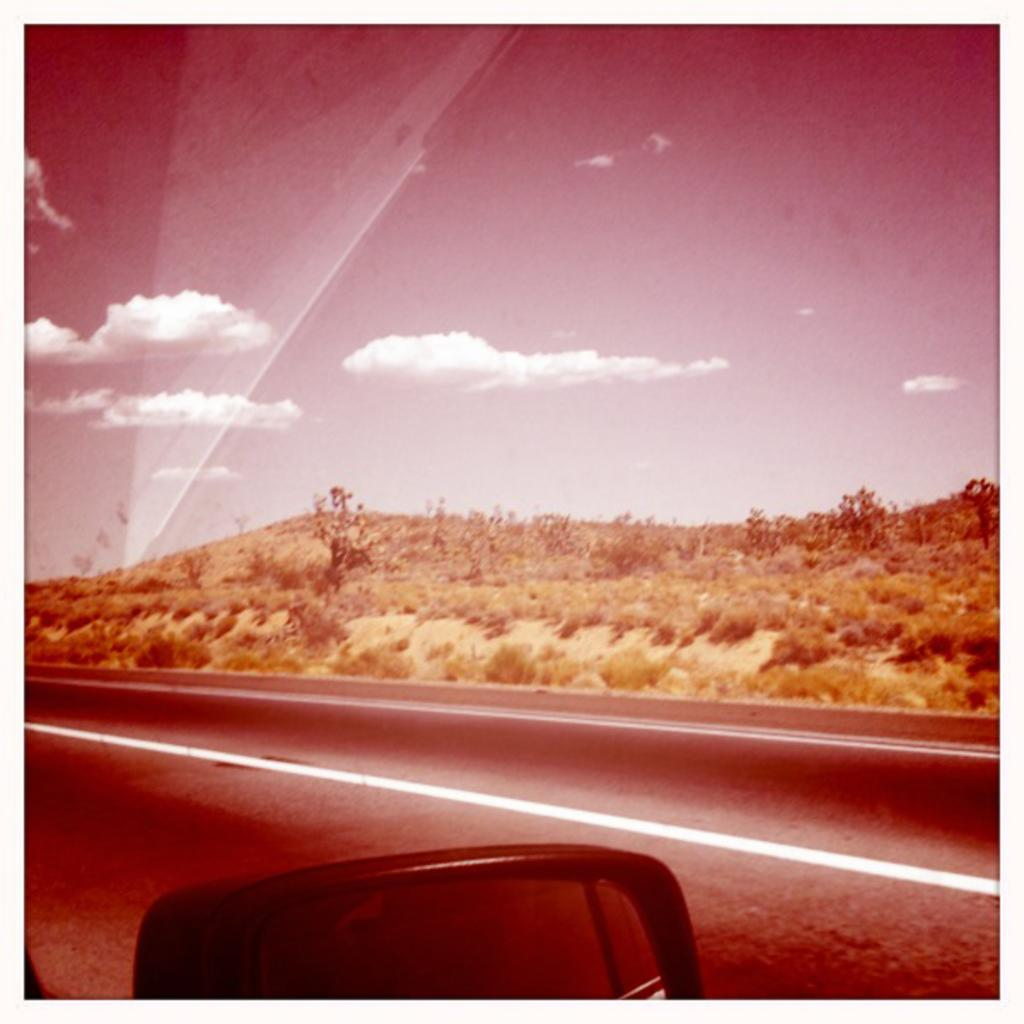What type of vegetation can be seen in the image? There are trees in the image. What is the color of the trees? The trees are green in color. What else is visible in the image besides the trees? The sky is visible in the image. What is the color of the sky? The sky is white in color. Can you identify any man-made objects in the image? Yes, there is a vehicle mirror in the image. Where is the goldfish swimming in the image? There is no goldfish present in the image. What type of roll can be seen in the image? There is no roll present in the image. 